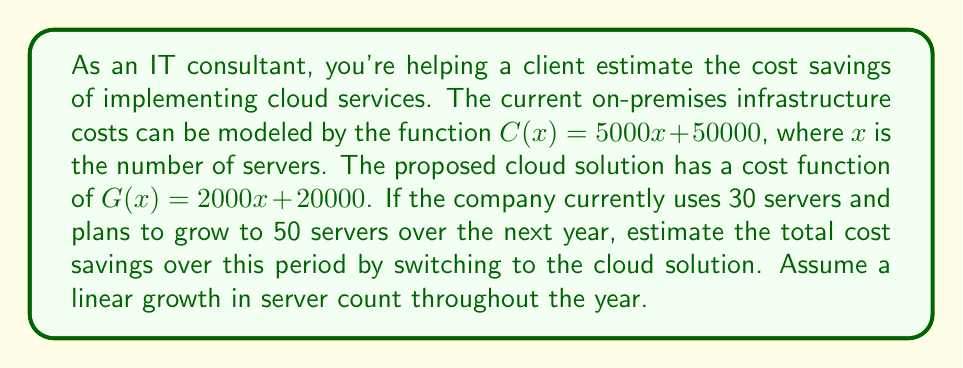Help me with this question. Let's approach this problem step-by-step:

1) First, we need to calculate the cost for both solutions at the beginning (30 servers) and end (50 servers) of the year.

   For on-premises:
   $C(30) = 5000(30) + 50000 = 200000$
   $C(50) = 5000(50) + 50000 = 300000$

   For cloud:
   $G(30) = 2000(30) + 20000 = 80000$
   $G(50) = 2000(50) + 20000 = 120000$

2) The company's server count grows linearly from 30 to 50 over the year. This means the average number of servers throughout the year is the midpoint: $(30 + 50) / 2 = 40$ servers.

3) We can use this average to calculate the average cost for each solution:

   Average on-premises cost: $C(40) = 5000(40) + 50000 = 250000$
   Average cloud cost: $G(40) = 2000(40) + 20000 = 100000$

4) The cost savings is the difference between these averages:

   $\text{Savings} = C(40) - G(40) = 250000 - 100000 = 150000$

Therefore, the estimated cost savings over the year is $150,000.
Answer: $150,000 